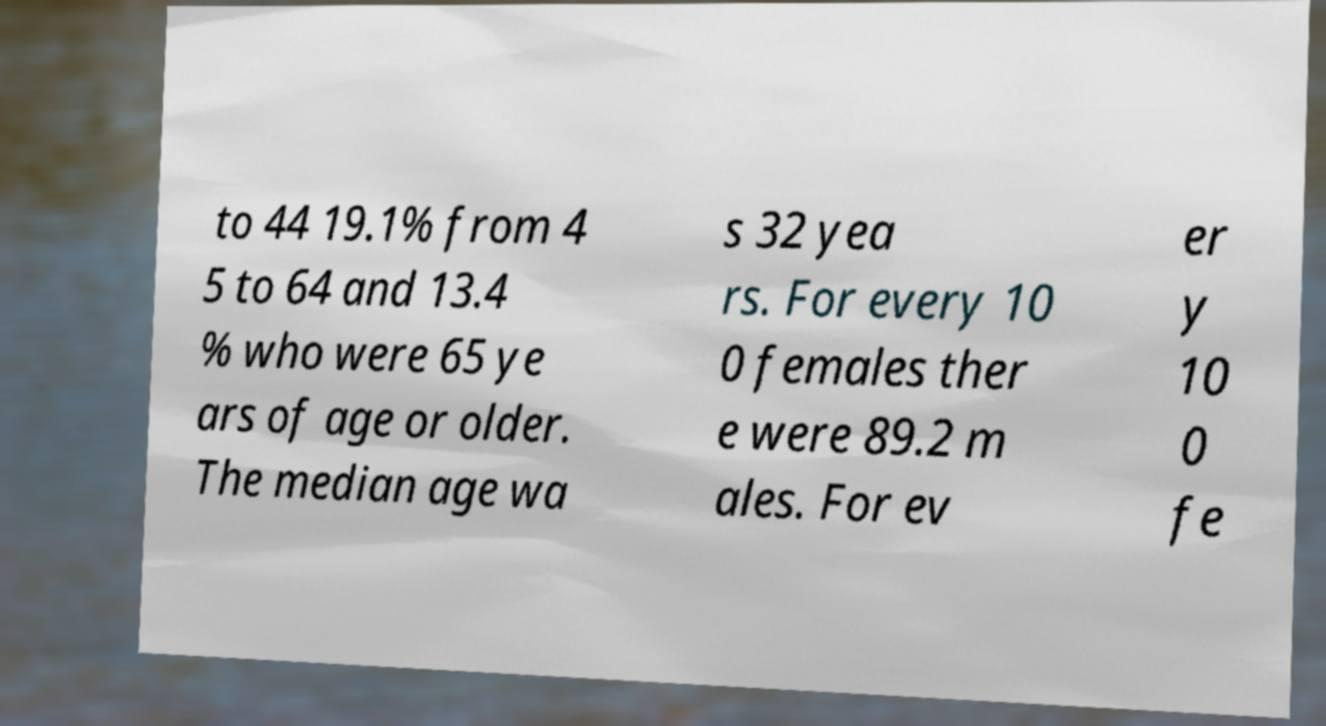For documentation purposes, I need the text within this image transcribed. Could you provide that? to 44 19.1% from 4 5 to 64 and 13.4 % who were 65 ye ars of age or older. The median age wa s 32 yea rs. For every 10 0 females ther e were 89.2 m ales. For ev er y 10 0 fe 